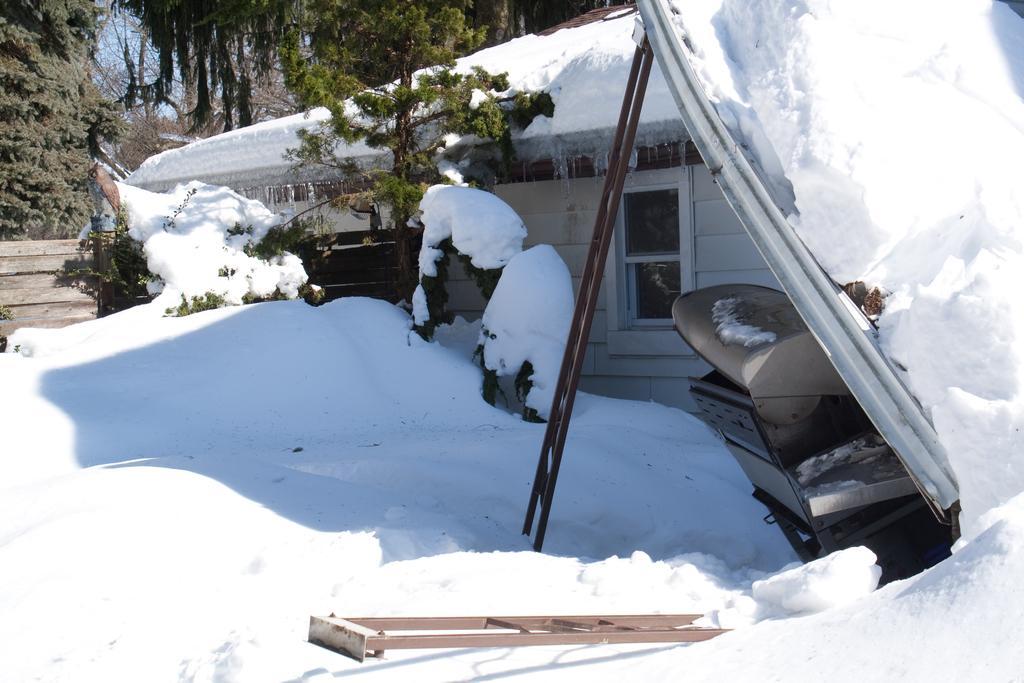Please provide a concise description of this image. Here we see a house covered with snow and few trees around. 